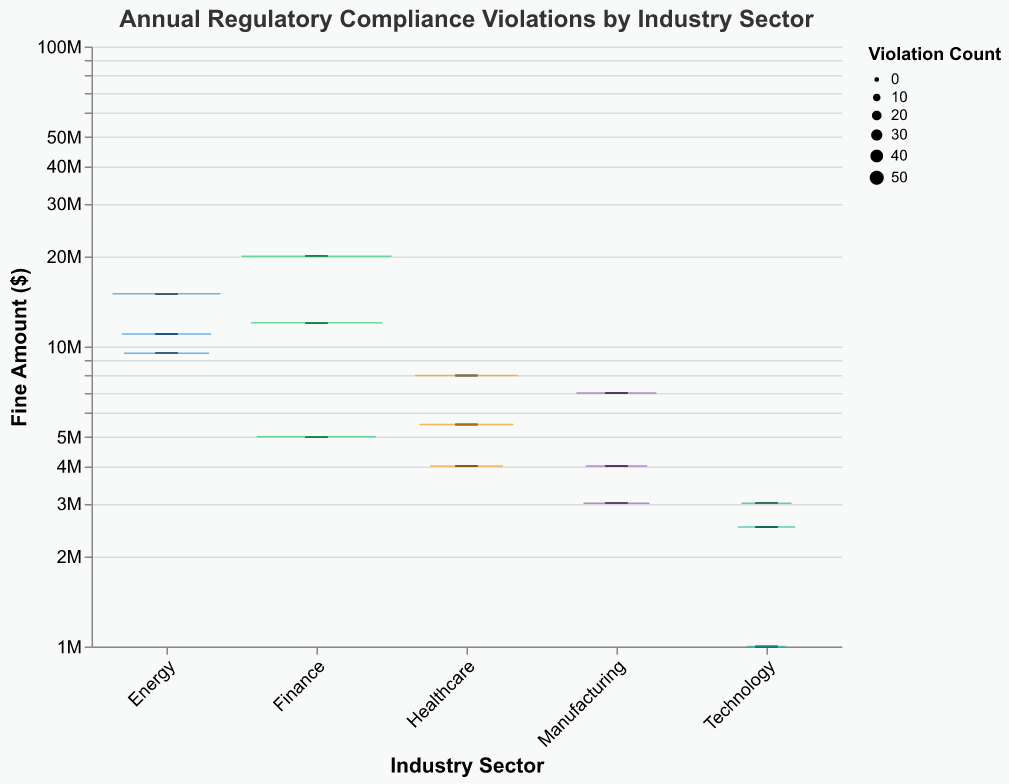What's the title of the plot? The title is displayed at the top of the plot.
Answer: Annual Regulatory Compliance Violations by Industry Sector Which industry has the most violations? The size of the boxes represents the violation count. The Finance sector has the largest box, indicating the highest number of violations.
Answer: Finance What is the median fine amount for the Healthcare sector? The median is depicted by a line within the box. In the Healthcare sector, the median fine amount is around $5,500,000.
Answer: $5,500,000 How does the range of fines in the Technology sector compare to the Energy sector? The Technology sector has a smaller range of fines with the minimum and maximum being $1,000,000 and $3,000,000, respectively. The Energy sector has a wider range with fines ranging from $9,500,000 to $15,000,000.
Answer: The Technology sector has a smaller range of fines than the Energy sector Which industry has the lowest maximum fine amount? The maximum fine amount is indicated by the top whisker of the box. The Technology sector has the lowest maximum fine amount, which is $3,000,000.
Answer: Technology What can you infer about the distribution of fines in the Manufacturing sector? The Manufacturing sector has fines ranging from $3,000,000 to $7,000,000 with a median of about $4,000,000. The distribution appears symmetric and relatively narrow compared to other sectors.
Answer: Symmetric and relatively narrow distribution Which industry has the highest median fine amount? The highest median fine amount is indicated by the median line within the boxes. The Finance sector has the highest median fine amount, which is around $12,000,000.
Answer: Finance How do violation counts affect the box plot's appearance? The width of the boxes in the box plot represents the violation count, with wider boxes indicating higher counts. For instance, the Finance sector has the widest box, reflecting its higher violation count.
Answer: Wider boxes mean higher violation counts What is the relationship between fine amounts and violation counts in the Healthcare sector? The Healthcare sector's fine amounts range from $4,000,000 to $8,000,000. The sizes of the boxes indicate that higher violation counts tend to be associated with higher fine amounts within this range.
Answer: Higher violation counts are associated with higher fine amounts Which sector shows the most variability in fine amounts? Variability is indicated by the range between the minimum and maximum values. The Energy sector shows the most variability with fines ranging from $9,500,000 to $15,000,000.
Answer: Energy 